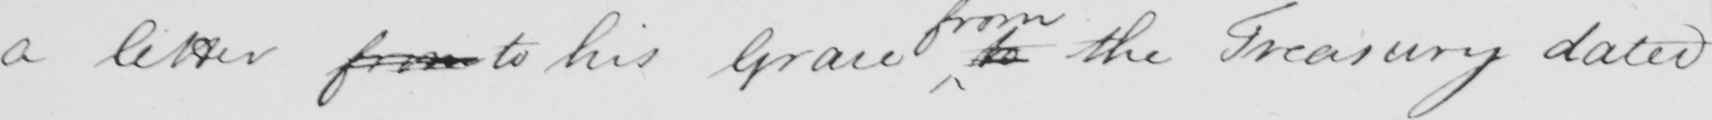Transcribe the text shown in this historical manuscript line. a letter from to his Grace to the Treasury dated 